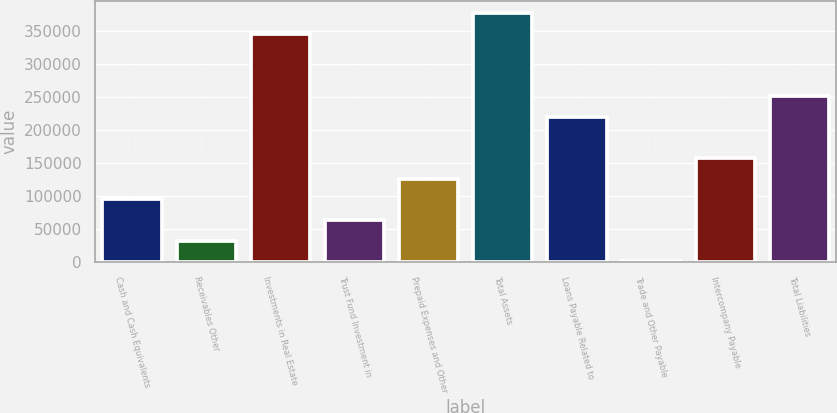<chart> <loc_0><loc_0><loc_500><loc_500><bar_chart><fcel>Cash and Cash Equivalents<fcel>Receivables Other<fcel>Investments in Real Estate<fcel>Trust Fund Investment in<fcel>Prepaid Expenses and Other<fcel>Total Assets<fcel>Loans Payable Related to<fcel>Trade and Other Payable<fcel>Intercompany Payable<fcel>Total Liabilities<nl><fcel>95769.8<fcel>33232.6<fcel>345919<fcel>64501.2<fcel>127038<fcel>377187<fcel>220844<fcel>1964<fcel>158307<fcel>252113<nl></chart> 